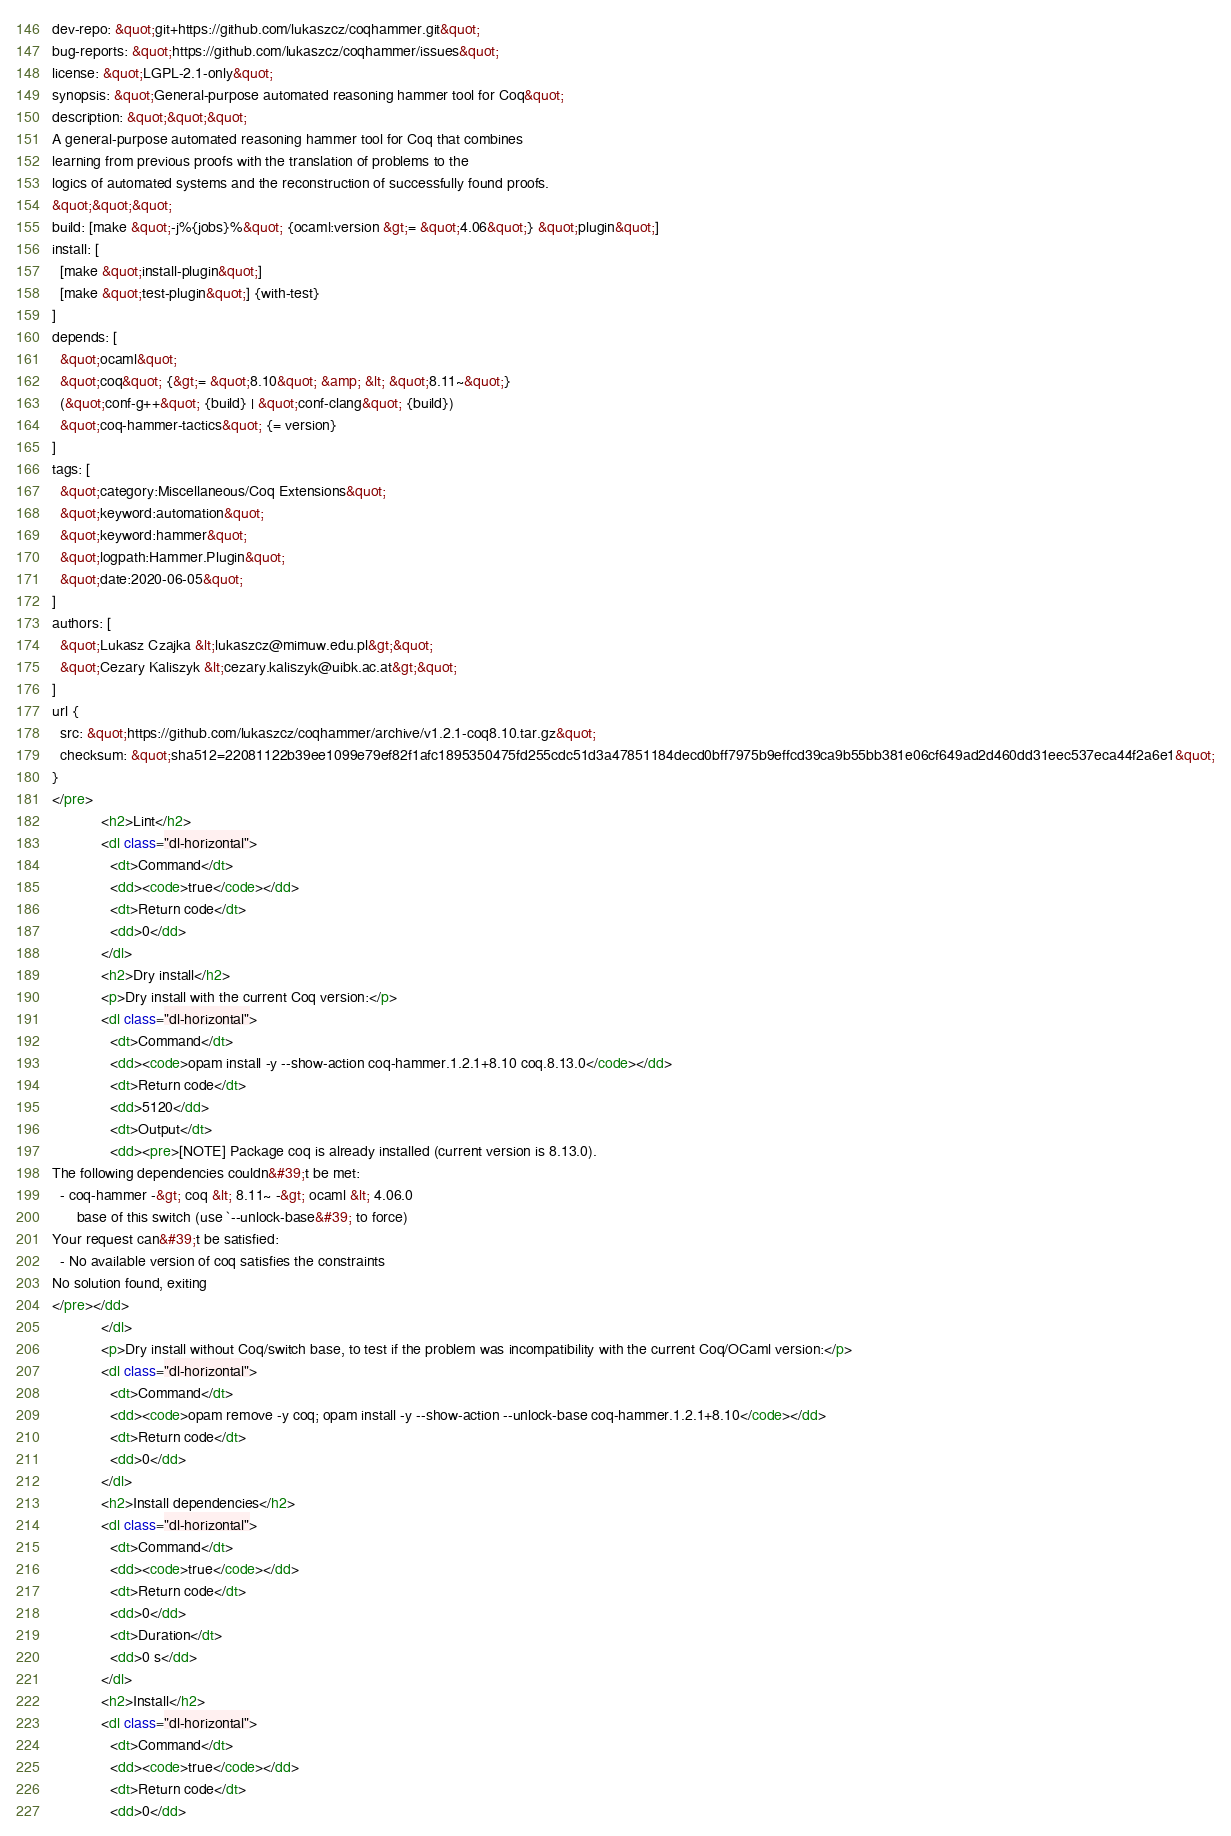Convert code to text. <code><loc_0><loc_0><loc_500><loc_500><_HTML_>dev-repo: &quot;git+https://github.com/lukaszcz/coqhammer.git&quot;
bug-reports: &quot;https://github.com/lukaszcz/coqhammer/issues&quot;
license: &quot;LGPL-2.1-only&quot;
synopsis: &quot;General-purpose automated reasoning hammer tool for Coq&quot;
description: &quot;&quot;&quot;
A general-purpose automated reasoning hammer tool for Coq that combines
learning from previous proofs with the translation of problems to the
logics of automated systems and the reconstruction of successfully found proofs.
&quot;&quot;&quot;
build: [make &quot;-j%{jobs}%&quot; {ocaml:version &gt;= &quot;4.06&quot;} &quot;plugin&quot;]
install: [
  [make &quot;install-plugin&quot;]
  [make &quot;test-plugin&quot;] {with-test}
]
depends: [
  &quot;ocaml&quot;
  &quot;coq&quot; {&gt;= &quot;8.10&quot; &amp; &lt; &quot;8.11~&quot;}
  (&quot;conf-g++&quot; {build} | &quot;conf-clang&quot; {build})
  &quot;coq-hammer-tactics&quot; {= version}
]
tags: [
  &quot;category:Miscellaneous/Coq Extensions&quot;
  &quot;keyword:automation&quot;
  &quot;keyword:hammer&quot;
  &quot;logpath:Hammer.Plugin&quot;
  &quot;date:2020-06-05&quot;
]
authors: [
  &quot;Lukasz Czajka &lt;lukaszcz@mimuw.edu.pl&gt;&quot;
  &quot;Cezary Kaliszyk &lt;cezary.kaliszyk@uibk.ac.at&gt;&quot;
]
url {
  src: &quot;https://github.com/lukaszcz/coqhammer/archive/v1.2.1-coq8.10.tar.gz&quot;
  checksum: &quot;sha512=22081122b39ee1099e79ef82f1afc1895350475fd255cdc51d3a47851184decd0bff7975b9effcd39ca9b55bb381e06cf649ad2d460dd31eec537eca44f2a6e1&quot;
}
</pre>
            <h2>Lint</h2>
            <dl class="dl-horizontal">
              <dt>Command</dt>
              <dd><code>true</code></dd>
              <dt>Return code</dt>
              <dd>0</dd>
            </dl>
            <h2>Dry install</h2>
            <p>Dry install with the current Coq version:</p>
            <dl class="dl-horizontal">
              <dt>Command</dt>
              <dd><code>opam install -y --show-action coq-hammer.1.2.1+8.10 coq.8.13.0</code></dd>
              <dt>Return code</dt>
              <dd>5120</dd>
              <dt>Output</dt>
              <dd><pre>[NOTE] Package coq is already installed (current version is 8.13.0).
The following dependencies couldn&#39;t be met:
  - coq-hammer -&gt; coq &lt; 8.11~ -&gt; ocaml &lt; 4.06.0
      base of this switch (use `--unlock-base&#39; to force)
Your request can&#39;t be satisfied:
  - No available version of coq satisfies the constraints
No solution found, exiting
</pre></dd>
            </dl>
            <p>Dry install without Coq/switch base, to test if the problem was incompatibility with the current Coq/OCaml version:</p>
            <dl class="dl-horizontal">
              <dt>Command</dt>
              <dd><code>opam remove -y coq; opam install -y --show-action --unlock-base coq-hammer.1.2.1+8.10</code></dd>
              <dt>Return code</dt>
              <dd>0</dd>
            </dl>
            <h2>Install dependencies</h2>
            <dl class="dl-horizontal">
              <dt>Command</dt>
              <dd><code>true</code></dd>
              <dt>Return code</dt>
              <dd>0</dd>
              <dt>Duration</dt>
              <dd>0 s</dd>
            </dl>
            <h2>Install</h2>
            <dl class="dl-horizontal">
              <dt>Command</dt>
              <dd><code>true</code></dd>
              <dt>Return code</dt>
              <dd>0</dd></code> 